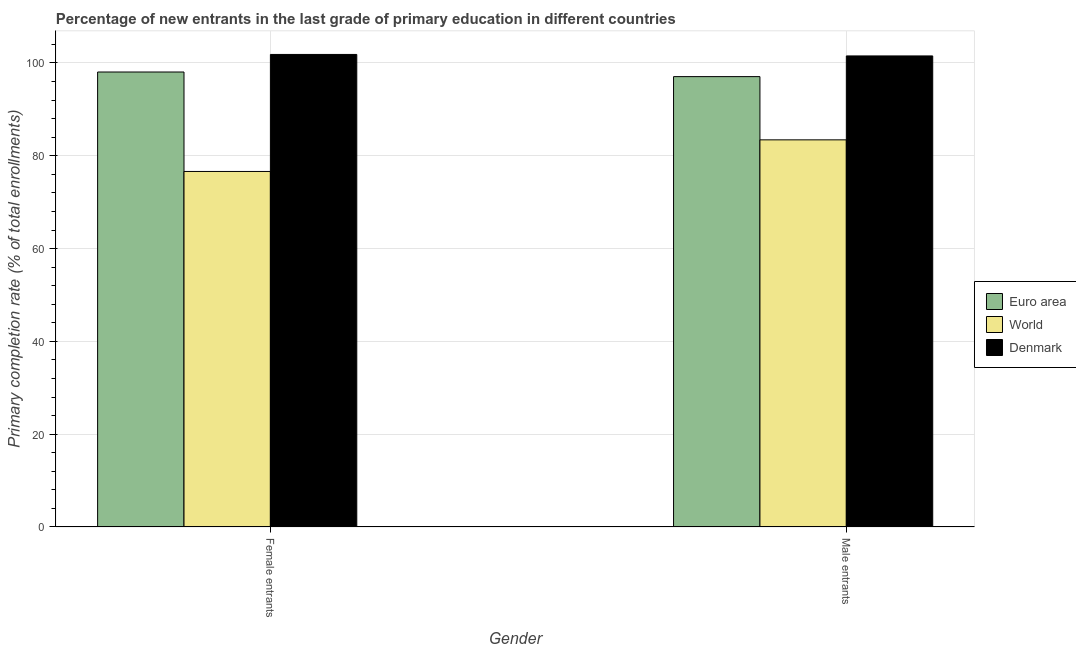How many different coloured bars are there?
Your answer should be very brief. 3. How many groups of bars are there?
Ensure brevity in your answer.  2. Are the number of bars per tick equal to the number of legend labels?
Offer a very short reply. Yes. How many bars are there on the 1st tick from the left?
Your answer should be very brief. 3. What is the label of the 1st group of bars from the left?
Ensure brevity in your answer.  Female entrants. What is the primary completion rate of male entrants in Denmark?
Offer a very short reply. 101.51. Across all countries, what is the maximum primary completion rate of male entrants?
Provide a short and direct response. 101.51. Across all countries, what is the minimum primary completion rate of male entrants?
Your answer should be very brief. 83.43. In which country was the primary completion rate of female entrants minimum?
Offer a very short reply. World. What is the total primary completion rate of female entrants in the graph?
Your response must be concise. 276.5. What is the difference between the primary completion rate of male entrants in Denmark and that in World?
Keep it short and to the point. 18.08. What is the difference between the primary completion rate of male entrants in World and the primary completion rate of female entrants in Euro area?
Provide a succinct answer. -14.62. What is the average primary completion rate of male entrants per country?
Offer a very short reply. 94. What is the difference between the primary completion rate of male entrants and primary completion rate of female entrants in Euro area?
Ensure brevity in your answer.  -0.99. In how many countries, is the primary completion rate of female entrants greater than 76 %?
Provide a succinct answer. 3. What is the ratio of the primary completion rate of male entrants in Euro area to that in Denmark?
Provide a succinct answer. 0.96. What does the 2nd bar from the right in Male entrants represents?
Your answer should be very brief. World. How many bars are there?
Offer a terse response. 6. Are all the bars in the graph horizontal?
Provide a succinct answer. No. Does the graph contain grids?
Give a very brief answer. Yes. What is the title of the graph?
Provide a succinct answer. Percentage of new entrants in the last grade of primary education in different countries. Does "North America" appear as one of the legend labels in the graph?
Offer a terse response. No. What is the label or title of the X-axis?
Provide a short and direct response. Gender. What is the label or title of the Y-axis?
Provide a succinct answer. Primary completion rate (% of total enrollments). What is the Primary completion rate (% of total enrollments) in Euro area in Female entrants?
Offer a terse response. 98.05. What is the Primary completion rate (% of total enrollments) of World in Female entrants?
Provide a short and direct response. 76.62. What is the Primary completion rate (% of total enrollments) of Denmark in Female entrants?
Offer a terse response. 101.83. What is the Primary completion rate (% of total enrollments) in Euro area in Male entrants?
Your answer should be compact. 97.06. What is the Primary completion rate (% of total enrollments) in World in Male entrants?
Your response must be concise. 83.43. What is the Primary completion rate (% of total enrollments) in Denmark in Male entrants?
Make the answer very short. 101.51. Across all Gender, what is the maximum Primary completion rate (% of total enrollments) in Euro area?
Your answer should be very brief. 98.05. Across all Gender, what is the maximum Primary completion rate (% of total enrollments) in World?
Provide a short and direct response. 83.43. Across all Gender, what is the maximum Primary completion rate (% of total enrollments) of Denmark?
Give a very brief answer. 101.83. Across all Gender, what is the minimum Primary completion rate (% of total enrollments) in Euro area?
Provide a succinct answer. 97.06. Across all Gender, what is the minimum Primary completion rate (% of total enrollments) of World?
Offer a very short reply. 76.62. Across all Gender, what is the minimum Primary completion rate (% of total enrollments) in Denmark?
Make the answer very short. 101.51. What is the total Primary completion rate (% of total enrollments) of Euro area in the graph?
Ensure brevity in your answer.  195.1. What is the total Primary completion rate (% of total enrollments) of World in the graph?
Provide a succinct answer. 160.04. What is the total Primary completion rate (% of total enrollments) of Denmark in the graph?
Your answer should be compact. 203.34. What is the difference between the Primary completion rate (% of total enrollments) of World in Female entrants and that in Male entrants?
Your response must be concise. -6.81. What is the difference between the Primary completion rate (% of total enrollments) of Denmark in Female entrants and that in Male entrants?
Give a very brief answer. 0.32. What is the difference between the Primary completion rate (% of total enrollments) in Euro area in Female entrants and the Primary completion rate (% of total enrollments) in World in Male entrants?
Give a very brief answer. 14.62. What is the difference between the Primary completion rate (% of total enrollments) in Euro area in Female entrants and the Primary completion rate (% of total enrollments) in Denmark in Male entrants?
Ensure brevity in your answer.  -3.46. What is the difference between the Primary completion rate (% of total enrollments) of World in Female entrants and the Primary completion rate (% of total enrollments) of Denmark in Male entrants?
Keep it short and to the point. -24.9. What is the average Primary completion rate (% of total enrollments) in Euro area per Gender?
Keep it short and to the point. 97.55. What is the average Primary completion rate (% of total enrollments) in World per Gender?
Your response must be concise. 80.02. What is the average Primary completion rate (% of total enrollments) of Denmark per Gender?
Provide a short and direct response. 101.67. What is the difference between the Primary completion rate (% of total enrollments) in Euro area and Primary completion rate (% of total enrollments) in World in Female entrants?
Make the answer very short. 21.43. What is the difference between the Primary completion rate (% of total enrollments) in Euro area and Primary completion rate (% of total enrollments) in Denmark in Female entrants?
Make the answer very short. -3.78. What is the difference between the Primary completion rate (% of total enrollments) of World and Primary completion rate (% of total enrollments) of Denmark in Female entrants?
Your answer should be very brief. -25.22. What is the difference between the Primary completion rate (% of total enrollments) in Euro area and Primary completion rate (% of total enrollments) in World in Male entrants?
Provide a succinct answer. 13.63. What is the difference between the Primary completion rate (% of total enrollments) of Euro area and Primary completion rate (% of total enrollments) of Denmark in Male entrants?
Make the answer very short. -4.46. What is the difference between the Primary completion rate (% of total enrollments) of World and Primary completion rate (% of total enrollments) of Denmark in Male entrants?
Give a very brief answer. -18.08. What is the ratio of the Primary completion rate (% of total enrollments) of Euro area in Female entrants to that in Male entrants?
Keep it short and to the point. 1.01. What is the ratio of the Primary completion rate (% of total enrollments) in World in Female entrants to that in Male entrants?
Provide a short and direct response. 0.92. What is the difference between the highest and the second highest Primary completion rate (% of total enrollments) in Euro area?
Provide a succinct answer. 0.99. What is the difference between the highest and the second highest Primary completion rate (% of total enrollments) in World?
Provide a succinct answer. 6.81. What is the difference between the highest and the second highest Primary completion rate (% of total enrollments) of Denmark?
Offer a terse response. 0.32. What is the difference between the highest and the lowest Primary completion rate (% of total enrollments) in World?
Offer a very short reply. 6.81. What is the difference between the highest and the lowest Primary completion rate (% of total enrollments) of Denmark?
Offer a terse response. 0.32. 